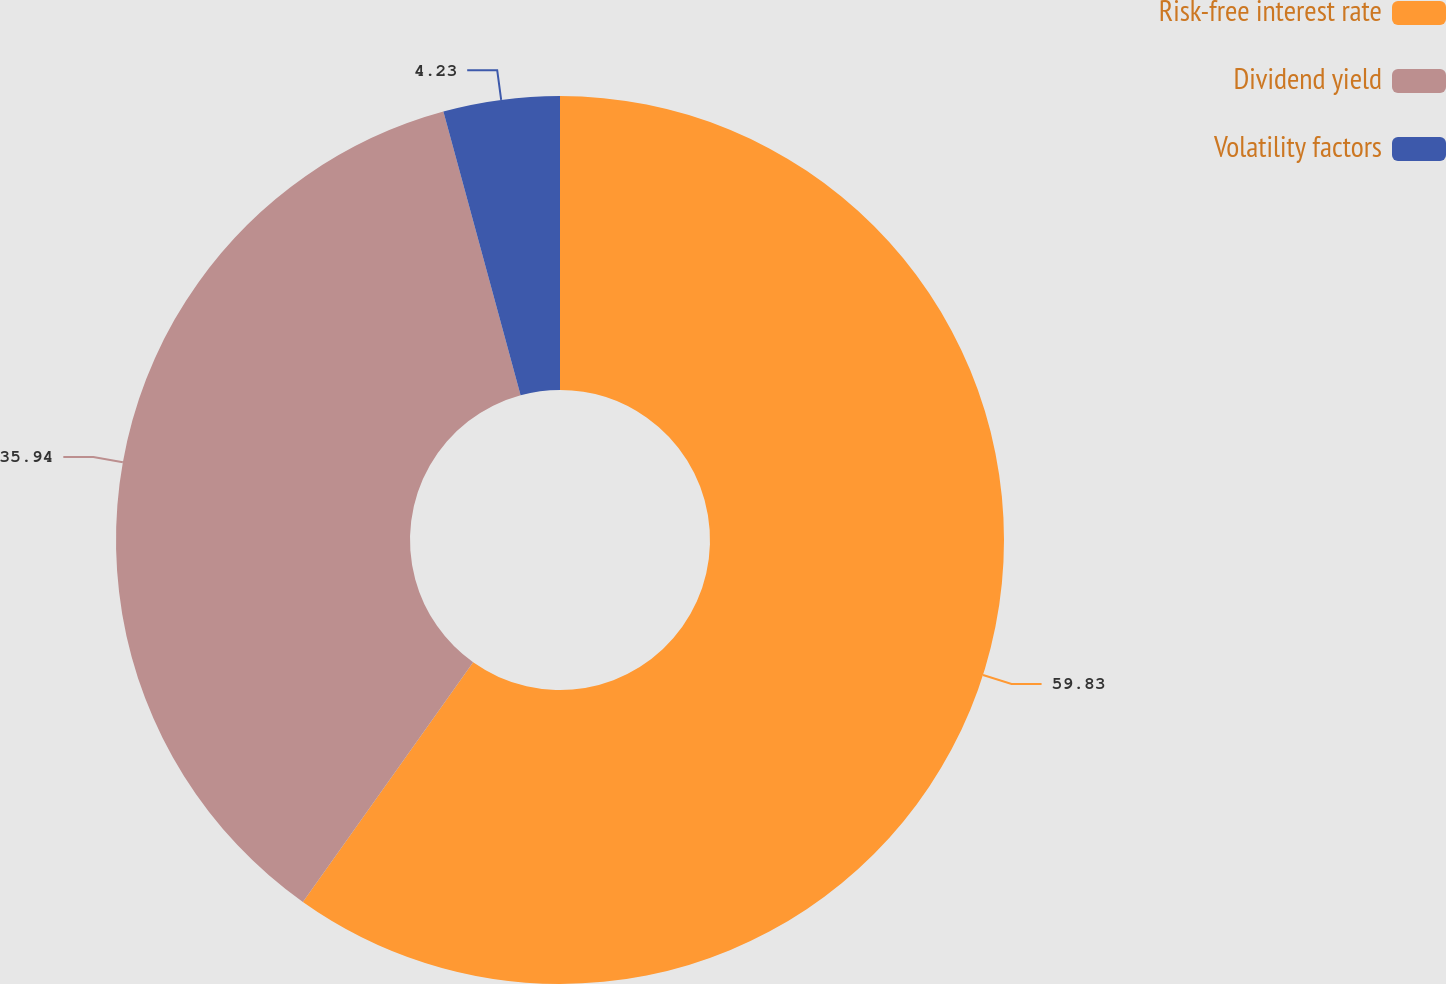<chart> <loc_0><loc_0><loc_500><loc_500><pie_chart><fcel>Risk-free interest rate<fcel>Dividend yield<fcel>Volatility factors<nl><fcel>59.83%<fcel>35.94%<fcel>4.23%<nl></chart> 